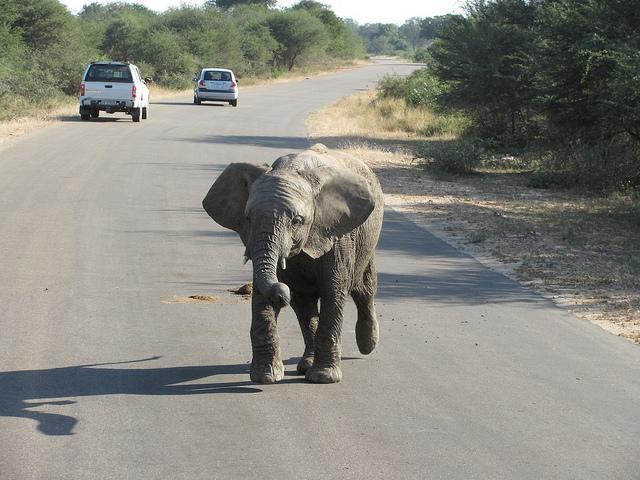How many cars are there?
Give a very brief answer. 2. 